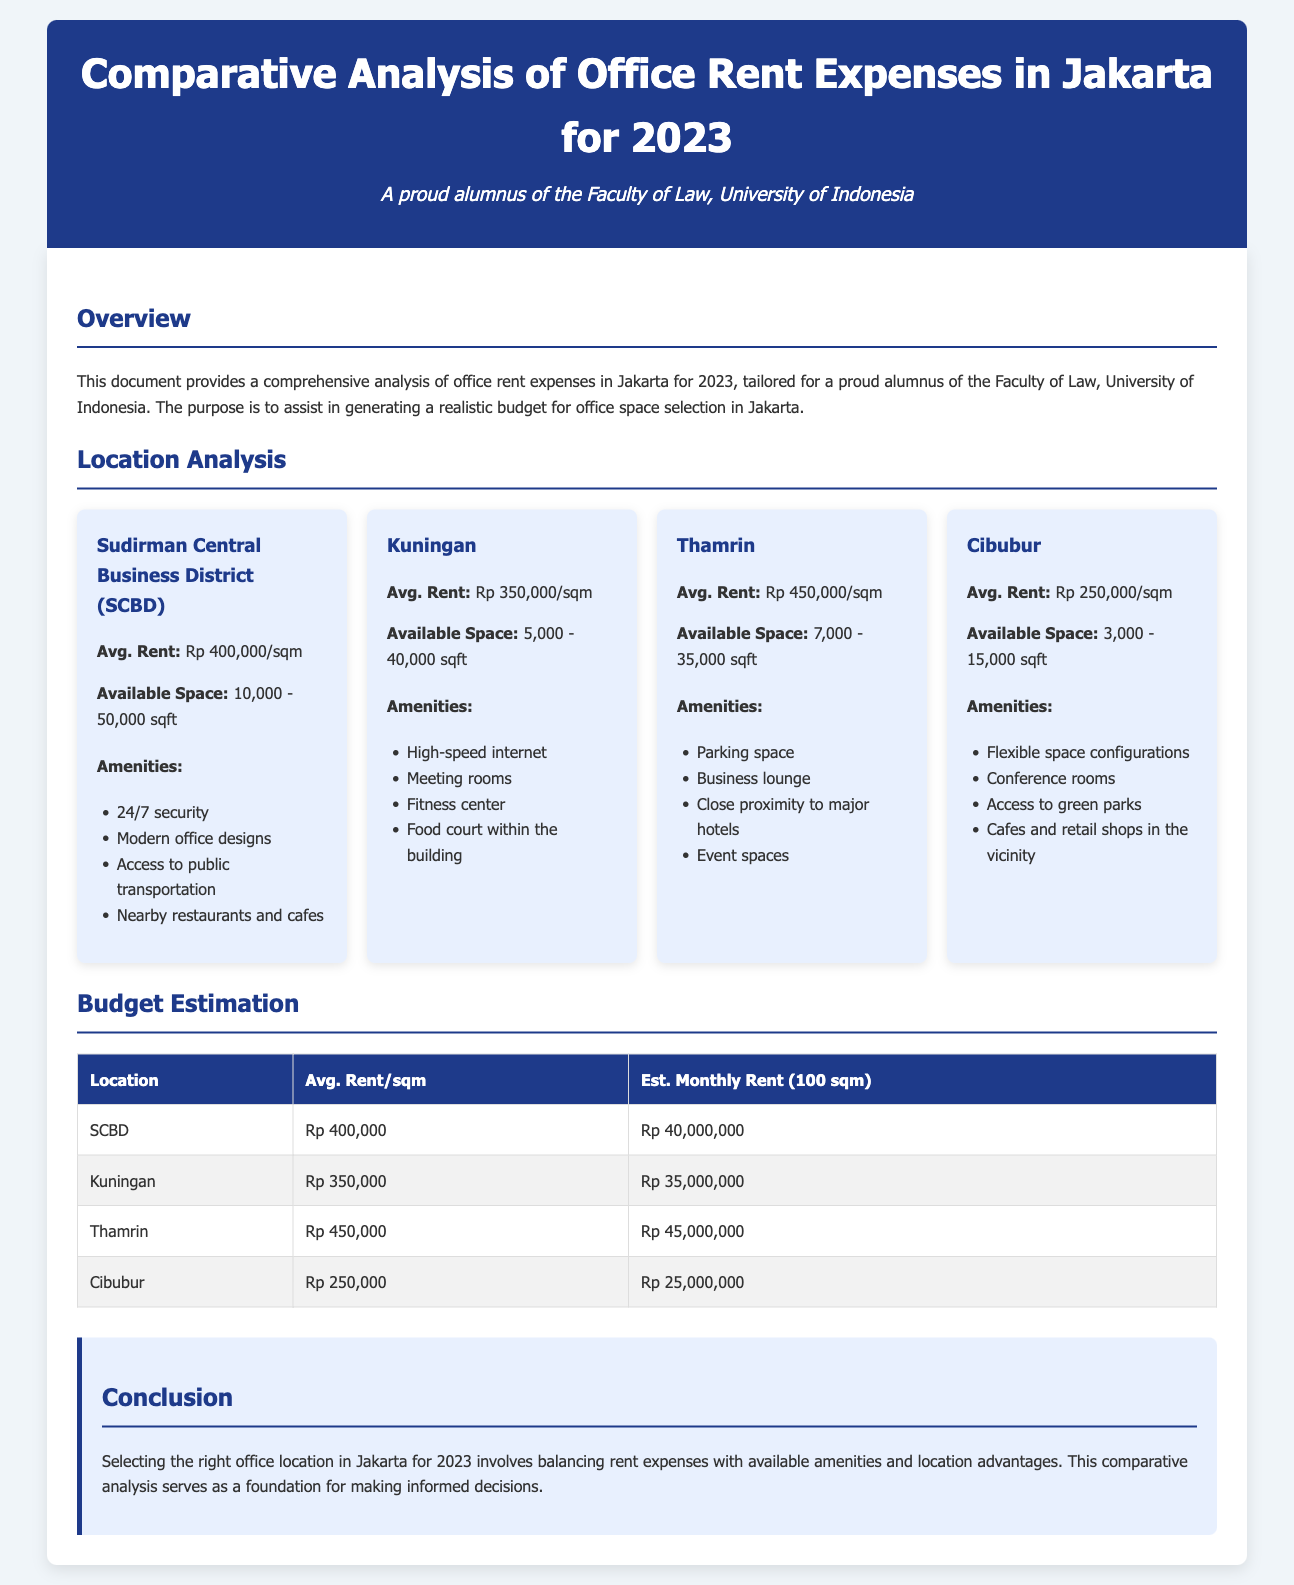What is the average rent per square meter in SCBD? The average rent in SCBD is explicitly stated in the document as Rp 400,000/sqm.
Answer: Rp 400,000/sqm What is the available space range in Kuningan? The document notes that available space in Kuningan ranges from 5,000 to 40,000 sqft.
Answer: 5,000 - 40,000 sqft Which location has the highest average rent? To determine the location with the highest average rent, one can compare the values provided, and Thamrin has the highest rate at Rp 450,000/sqm.
Answer: Thamrin How much is the estimated monthly rent for a 100 sqm office in Cibubur? The document provides an estimated monthly rent for Cibubur, which is Rp 25,000,000 for 100 sqm.
Answer: Rp 25,000,000 What amenities are listed for the Thamrin location? The Thamrin location's amenities listed include parking space, business lounge, close proximity to major hotels, and event spaces.
Answer: Parking space, business lounge, close proximity to major hotels, event spaces What is the total estimated monthly rent for SCBD and Kuningan combined? To find the combined total of the estimated monthly rent, add Rp 40,000,000 (SCBD) and Rp 35,000,000 (Kuningan) together, equaling Rp 75,000,000.
Answer: Rp 75,000,000 What amenities are mentioned for Cibubur? The available amenities in Cibubur include flexible space configurations, conference rooms, access to green parks, and cafes and retail shops in the vicinity.
Answer: Flexible space configurations, conference rooms, access to green parks, cafes and retail shops What is the purpose of this document? The purpose of the document is to assist in generating a realistic budget for office space selection in Jakarta based on the comparative analysis.
Answer: Assist in generating a realistic budget for office space selection in Jakarta 